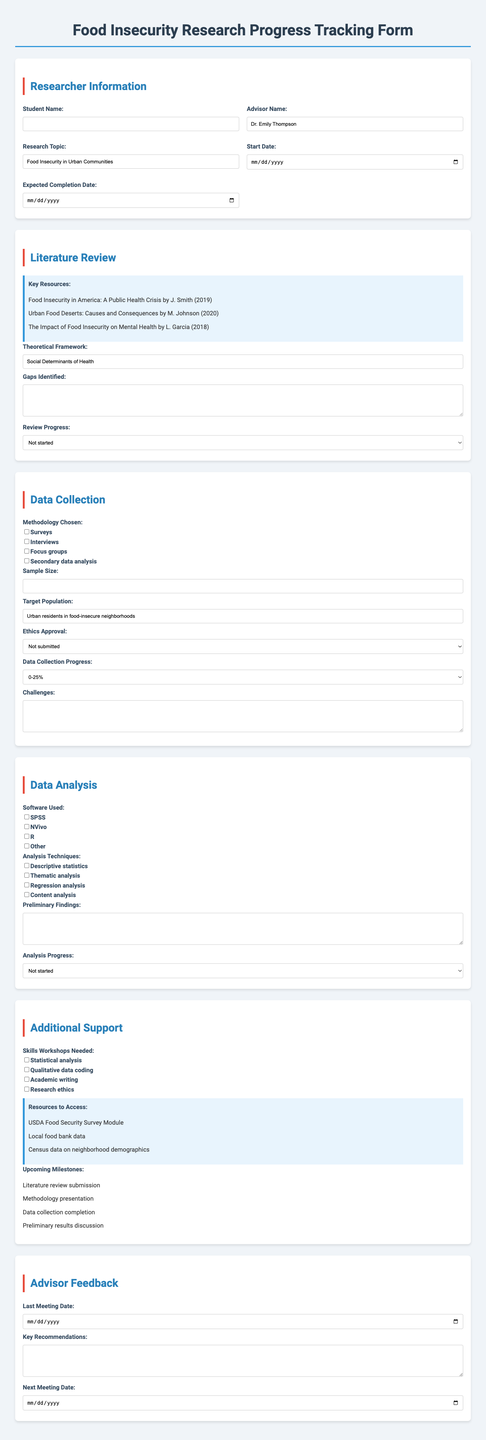What is the research topic? The research topic is specified in the researcher information section.
Answer: Food Insecurity in Urban Communities Who is the advisor? The advisor's name is provided in the researcher information section.
Answer: Dr. Emily Thompson What is the target population? The target population is indicated in the data collection section.
Answer: Urban residents in food-insecure neighborhoods What is the methodology chosen? The methodologies are listed in the data collection section, of which one may be highlighted.
Answer: Surveys How many key resources are listed? The number of key resources is found in the literature review section.
Answer: 3 What progress is reported for the literature review? The current status of the literature review is included under review progress.
Answer: Not started What analysis technique is mentioned? The analysis techniques are specified in the data analysis section.
Answer: Descriptive statistics What resources are to be accessed? The available resources for support are listed in the additional support section.
Answer: USDA Food Security Survey Module 